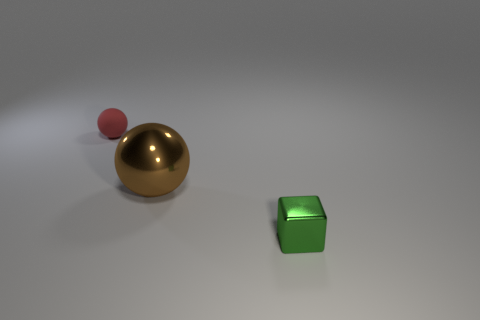Is there anything else that is the same color as the rubber object?
Provide a succinct answer. No. There is a thing that is both right of the red matte object and to the left of the tiny green cube; how big is it?
Your answer should be compact. Large. There is a ball in front of the small matte ball; is it the same color as the small thing right of the big thing?
Provide a short and direct response. No. What number of other things are made of the same material as the large ball?
Ensure brevity in your answer.  1. Is the color of the block the same as the tiny thing that is behind the green block?
Give a very brief answer. No. There is a ball to the right of the matte ball; is its size the same as the red sphere?
Your response must be concise. No. What is the material of the large brown thing that is the same shape as the small rubber object?
Provide a succinct answer. Metal. Does the tiny red matte object have the same shape as the big brown object?
Your answer should be compact. Yes. How many green cubes are left of the tiny thing that is in front of the small red matte thing?
Offer a terse response. 0. What shape is the other thing that is the same material as the big brown object?
Provide a short and direct response. Cube. 